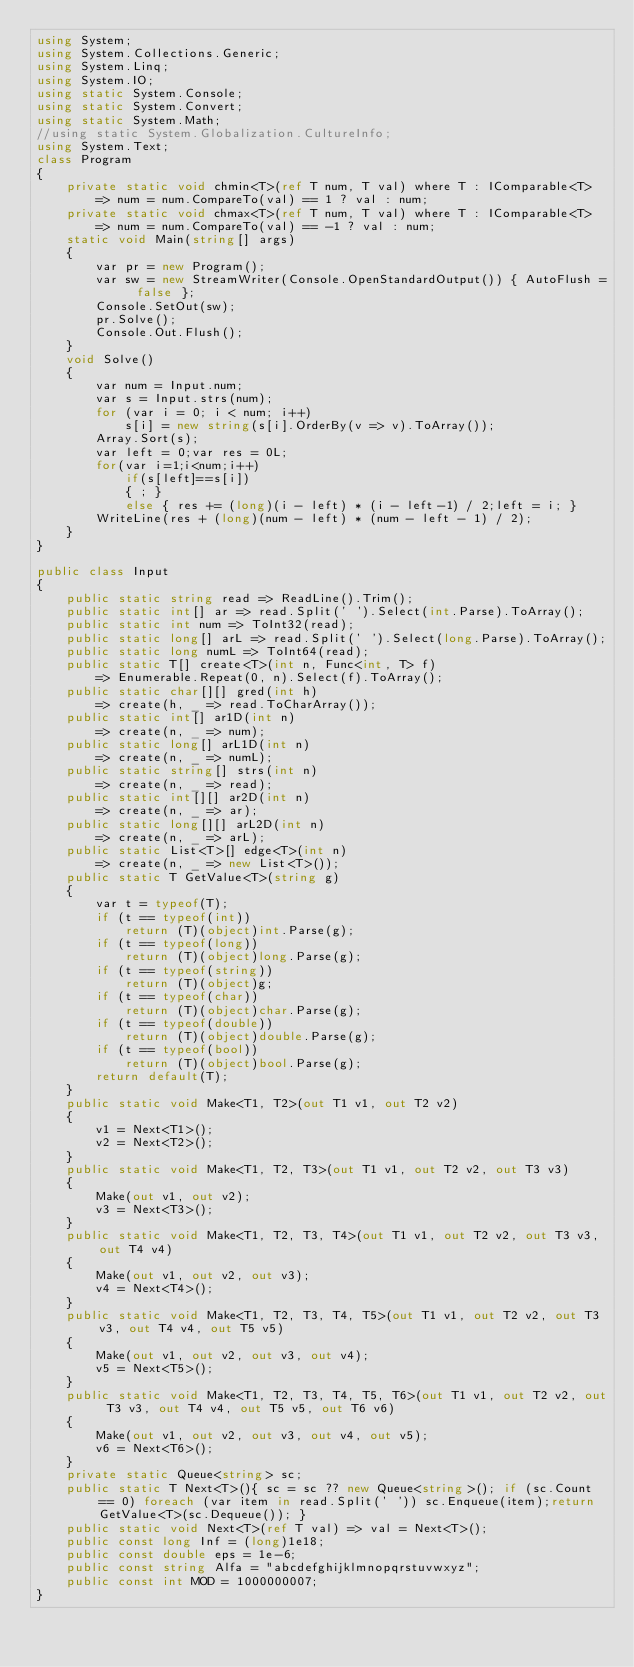<code> <loc_0><loc_0><loc_500><loc_500><_C#_>using System;
using System.Collections.Generic;
using System.Linq;
using System.IO;
using static System.Console;
using static System.Convert;
using static System.Math;
//using static System.Globalization.CultureInfo;
using System.Text;
class Program
{
    private static void chmin<T>(ref T num, T val) where T : IComparable<T>
        => num = num.CompareTo(val) == 1 ? val : num;
    private static void chmax<T>(ref T num, T val) where T : IComparable<T>
        => num = num.CompareTo(val) == -1 ? val : num;
    static void Main(string[] args)
    {
        var pr = new Program();
        var sw = new StreamWriter(Console.OpenStandardOutput()) { AutoFlush = false };
        Console.SetOut(sw);
        pr.Solve();
        Console.Out.Flush();
    }
    void Solve()
    {
        var num = Input.num;
        var s = Input.strs(num);
        for (var i = 0; i < num; i++)
            s[i] = new string(s[i].OrderBy(v => v).ToArray());
        Array.Sort(s);
        var left = 0;var res = 0L;
        for(var i=1;i<num;i++)
            if(s[left]==s[i])
            { ; }
            else { res += (long)(i - left) * (i - left-1) / 2;left = i; }
        WriteLine(res + (long)(num - left) * (num - left - 1) / 2);
    }
}

public class Input
{
    public static string read => ReadLine().Trim();
    public static int[] ar => read.Split(' ').Select(int.Parse).ToArray();
    public static int num => ToInt32(read);
    public static long[] arL => read.Split(' ').Select(long.Parse).ToArray();
    public static long numL => ToInt64(read);
    public static T[] create<T>(int n, Func<int, T> f)
        => Enumerable.Repeat(0, n).Select(f).ToArray();
    public static char[][] gred(int h)
        => create(h, _ => read.ToCharArray());
    public static int[] ar1D(int n)
        => create(n, _ => num);
    public static long[] arL1D(int n)
        => create(n, _ => numL);
    public static string[] strs(int n)
        => create(n, _ => read);
    public static int[][] ar2D(int n)
        => create(n, _ => ar);
    public static long[][] arL2D(int n)
        => create(n, _ => arL);
    public static List<T>[] edge<T>(int n)
        => create(n, _ => new List<T>());
    public static T GetValue<T>(string g)
    {
        var t = typeof(T);
        if (t == typeof(int))
            return (T)(object)int.Parse(g);
        if (t == typeof(long))
            return (T)(object)long.Parse(g);
        if (t == typeof(string))
            return (T)(object)g;
        if (t == typeof(char))
            return (T)(object)char.Parse(g);
        if (t == typeof(double))
            return (T)(object)double.Parse(g);
        if (t == typeof(bool))
            return (T)(object)bool.Parse(g);
        return default(T);
    }
    public static void Make<T1, T2>(out T1 v1, out T2 v2)
    {
        v1 = Next<T1>();
        v2 = Next<T2>();
    }
    public static void Make<T1, T2, T3>(out T1 v1, out T2 v2, out T3 v3)
    {
        Make(out v1, out v2);
        v3 = Next<T3>();
    }
    public static void Make<T1, T2, T3, T4>(out T1 v1, out T2 v2, out T3 v3, out T4 v4)
    {
        Make(out v1, out v2, out v3);
        v4 = Next<T4>();
    }
    public static void Make<T1, T2, T3, T4, T5>(out T1 v1, out T2 v2, out T3 v3, out T4 v4, out T5 v5)
    {
        Make(out v1, out v2, out v3, out v4);
        v5 = Next<T5>();
    }
    public static void Make<T1, T2, T3, T4, T5, T6>(out T1 v1, out T2 v2, out T3 v3, out T4 v4, out T5 v5, out T6 v6)
    {
        Make(out v1, out v2, out v3, out v4, out v5);
        v6 = Next<T6>();
    }
    private static Queue<string> sc;
    public static T Next<T>(){ sc = sc ?? new Queue<string>(); if (sc.Count == 0) foreach (var item in read.Split(' ')) sc.Enqueue(item);return GetValue<T>(sc.Dequeue()); }
    public static void Next<T>(ref T val) => val = Next<T>(); 
    public const long Inf = (long)1e18;
    public const double eps = 1e-6;
    public const string Alfa = "abcdefghijklmnopqrstuvwxyz";
    public const int MOD = 1000000007;
}</code> 